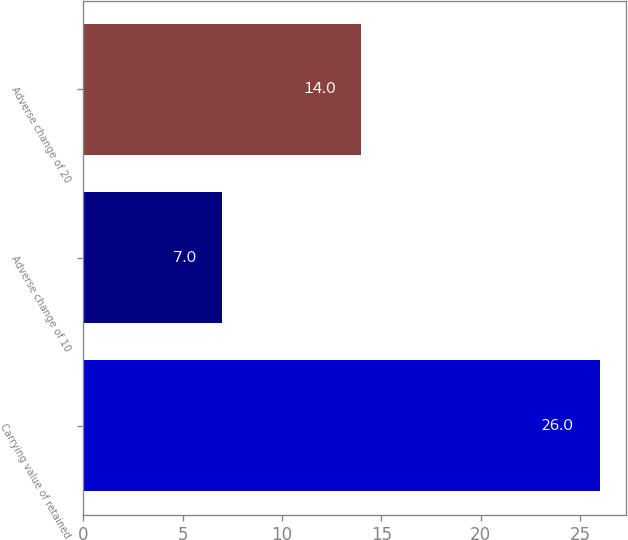Convert chart to OTSL. <chart><loc_0><loc_0><loc_500><loc_500><bar_chart><fcel>Carrying value of retained<fcel>Adverse change of 10<fcel>Adverse change of 20<nl><fcel>26<fcel>7<fcel>14<nl></chart> 